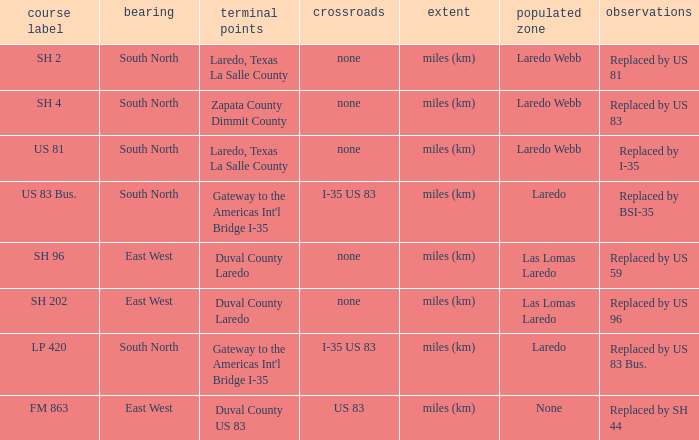How many junctions have "replaced by bsi-35" listed in their remarks section? 1.0. 